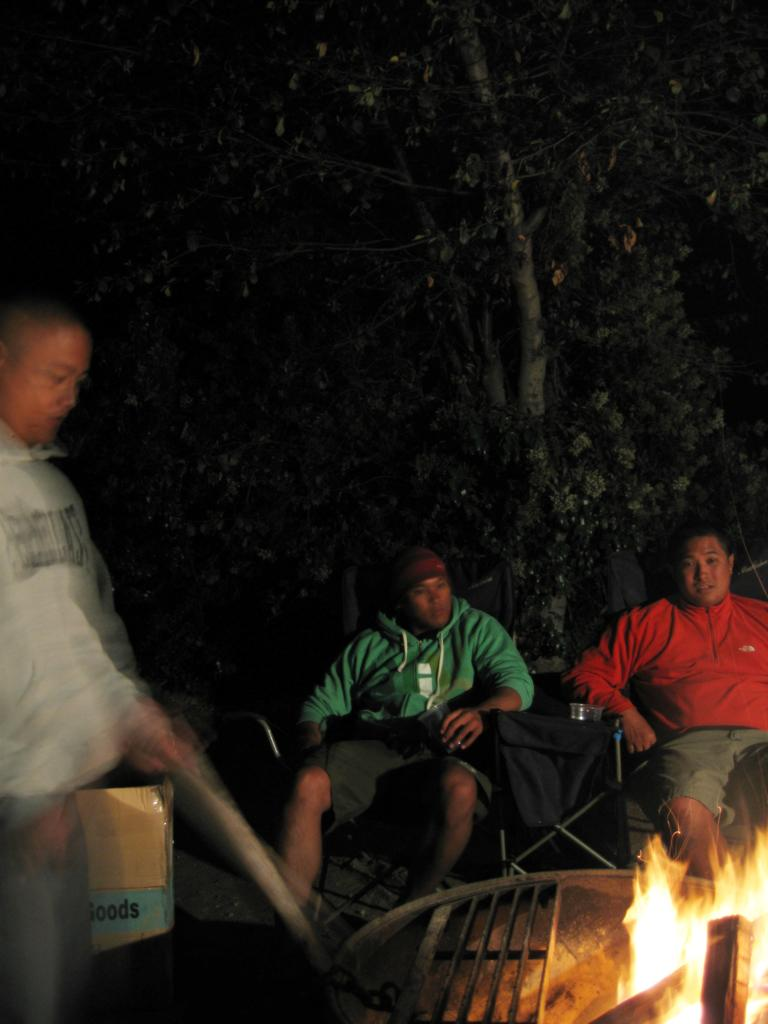What is the position of the person in the image? There is a person standing on the left side of the image. What can be seen in the bottom right side of the image? Fire is present in the bottom right side of the image. What are the people in the center of the image doing? There are people sitting in the center of the image. What type of environment is visible in the background of the image? Greenery is visible in the background of the image. What type of grape is being used as a form of currency in the image? There is no grape or currency present in the image. What type of class is being taught in the image? There is no class or teaching activity depicted in the image. 